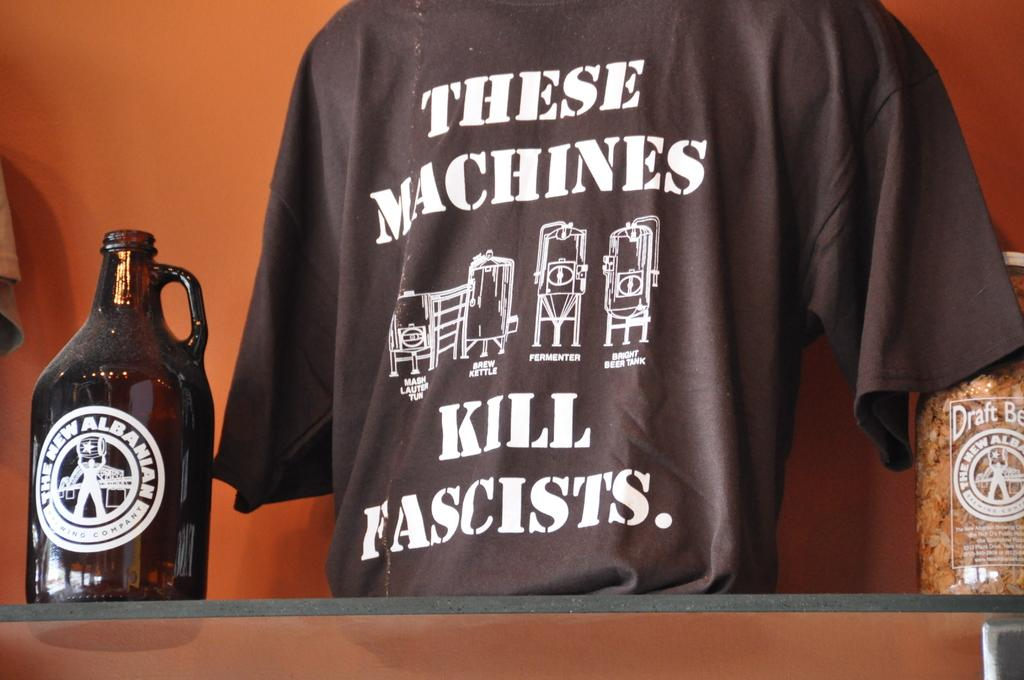What object is visible in the image that is made of glass? There is a glass jar in the image. Where is the glass jar located? The glass jar is on a glass shelf. What other item can be seen near the glass jar? There is a t-shirt beside the glass jar. How many cars are parked along the border in the image? There are no cars or borders present in the image; it features a glass jar on a glass shelf with a t-shirt beside it. 